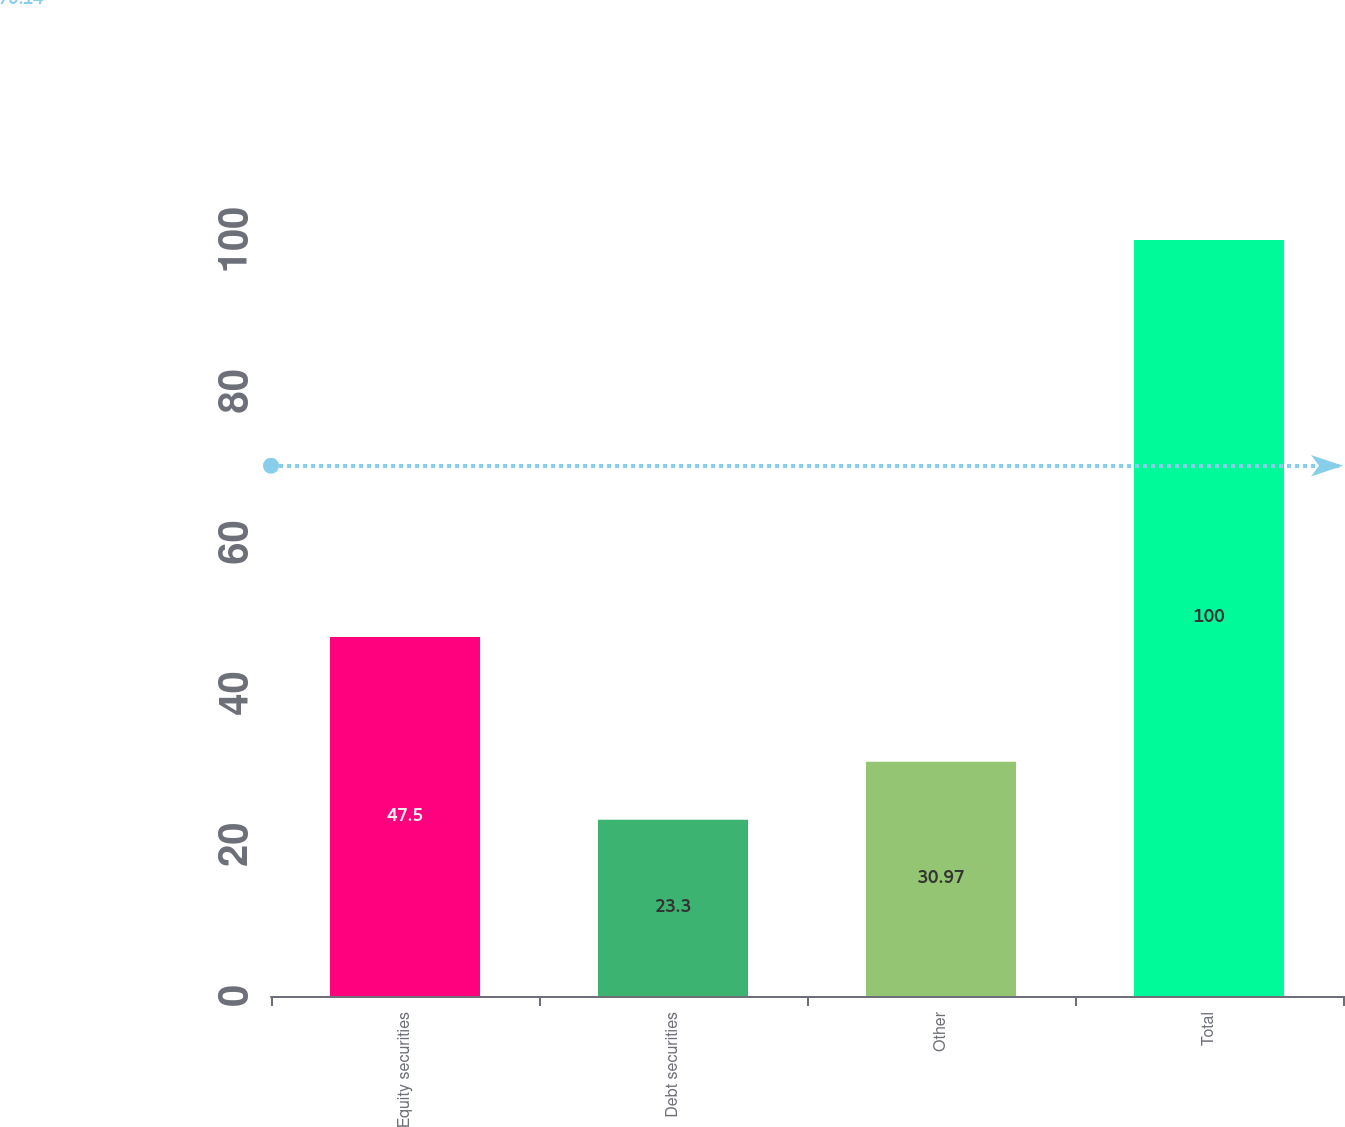Convert chart. <chart><loc_0><loc_0><loc_500><loc_500><bar_chart><fcel>Equity securities<fcel>Debt securities<fcel>Other<fcel>Total<nl><fcel>47.5<fcel>23.3<fcel>30.97<fcel>100<nl></chart> 